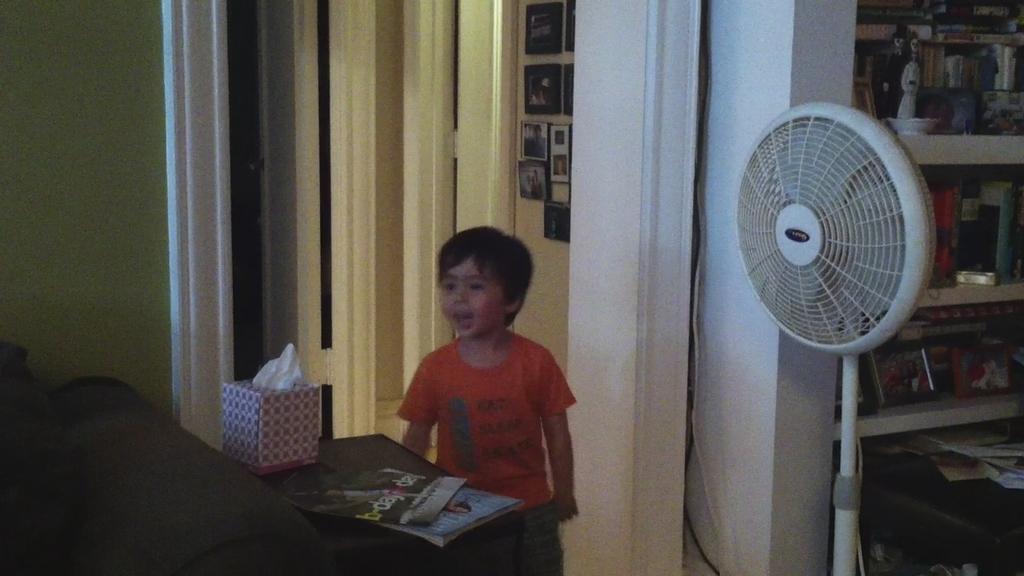Describe this image in one or two sentences. In this image I can see a child standing in the center. There are books and a tissue box in front of him. There is a table fan and shelves on the right. There are photo frames at the back. 